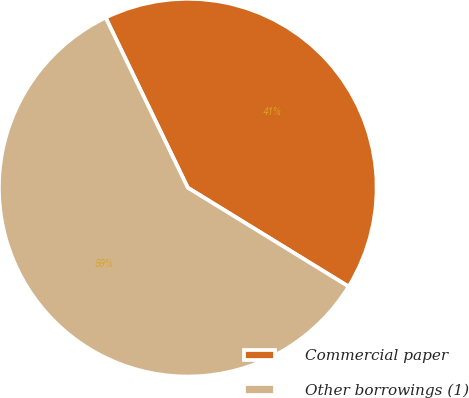Convert chart to OTSL. <chart><loc_0><loc_0><loc_500><loc_500><pie_chart><fcel>Commercial paper<fcel>Other borrowings (1)<nl><fcel>40.93%<fcel>59.07%<nl></chart> 